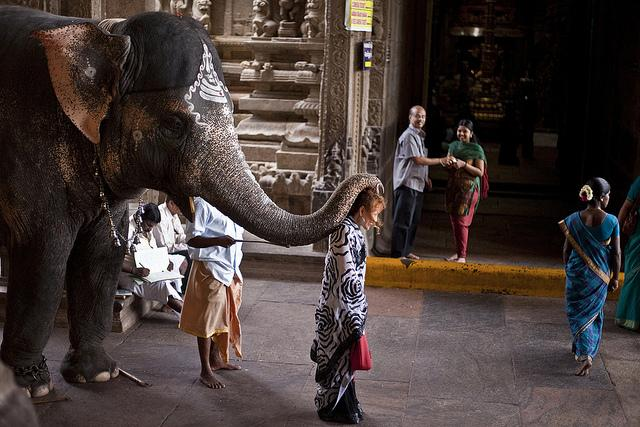What is the type of garment that the woman in blue is wearing? sari 